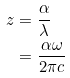Convert formula to latex. <formula><loc_0><loc_0><loc_500><loc_500>z & = \frac { \alpha } { \lambda } \\ & = \frac { \alpha \omega } { 2 \pi c }</formula> 